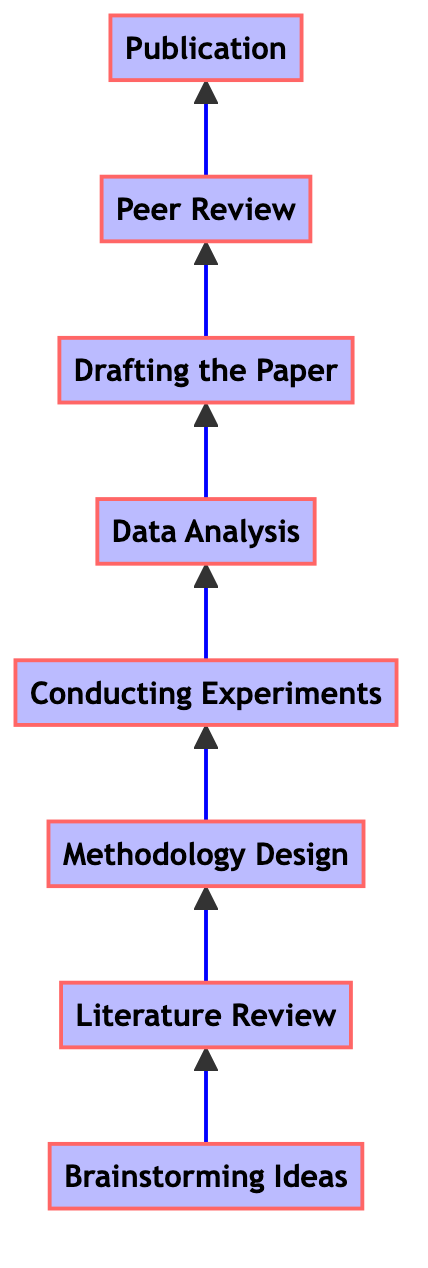What is the first stage in the research paper process? The first stage in the diagram is at the bottom, labeled "Brainstorming Ideas," which initiates the flow of the research paper writing process.
Answer: Brainstorming Ideas How many total stages are there in the diagram? By counting each of the stages represented as nodes in the flow chart, there are eight distinct stages starting from "Brainstorming Ideas" to "Publication."
Answer: 8 What is the stage directly above "Data Analysis"? "Drafting the Paper" is immediately positioned above "Data Analysis," indicating it follows this analytical process.
Answer: Drafting the Paper What is the last step before publication? The last step outlined before reaching "Publication" is "Peer Review," indicating that this is the final stage of evaluation before publishing.
Answer: Peer Review Which stage is reached after "Conducting Experiments"? After "Conducting Experiments," the next stage in the upward flow is "Data Analysis," marking the transition from experimenting to analyzing the results.
Answer: Data Analysis What method is suggested for generating ideas in the brainstorming stage? The diagram describes methods such as mind mapping and discussions with peers as approaches for generating research ideas in the "Brainstorming Ideas" stage.
Answer: Mind mapping What is the significance of "Literature Review" in the overall process? The "Literature Review" stage is significant because it allows researchers to identify gaps in existing research and relevant theories, which informs their methodology and focus of the study.
Answer: Identifying gaps What happens during the "Peer Review" stage? During the "Peer Review" stage, the paper is submitted to experts for evaluation, allowing for critical feedback that can enhance the quality of the paper before publication.
Answer: Evaluation by experts 